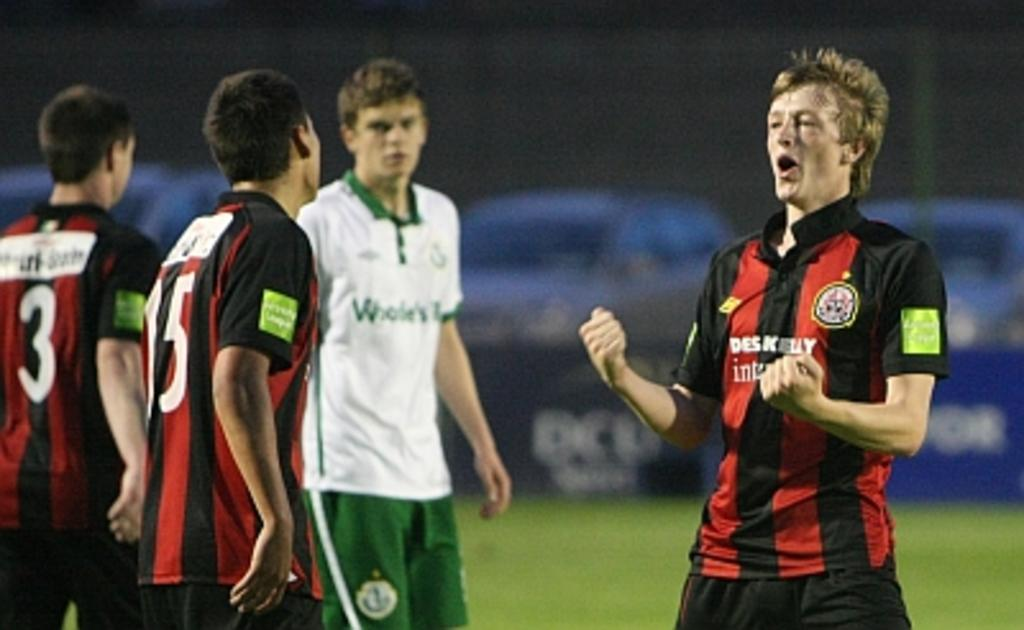<image>
Present a compact description of the photo's key features. Three soccer players are in a huddle with one having the numberr 15 on his back. 